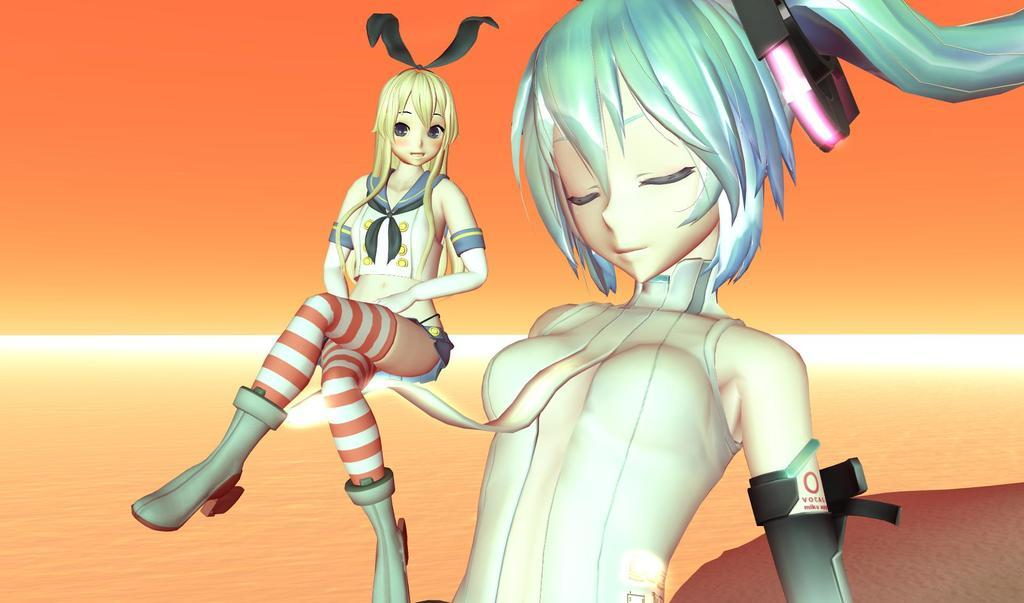What is the main subject of the image? The main subject of the image is two human cartoon pictures. Where are the human cartoon pictures located in the image? The human cartoon pictures are in the center of the image. How many trains can be seen in the image? There are no trains present in the image. What type of trail is visible in the image? There is no trail visible in the image. What action are the human cartoon pictures performing in the image? The provided facts do not specify any actions being performed by the human cartoon pictures. 